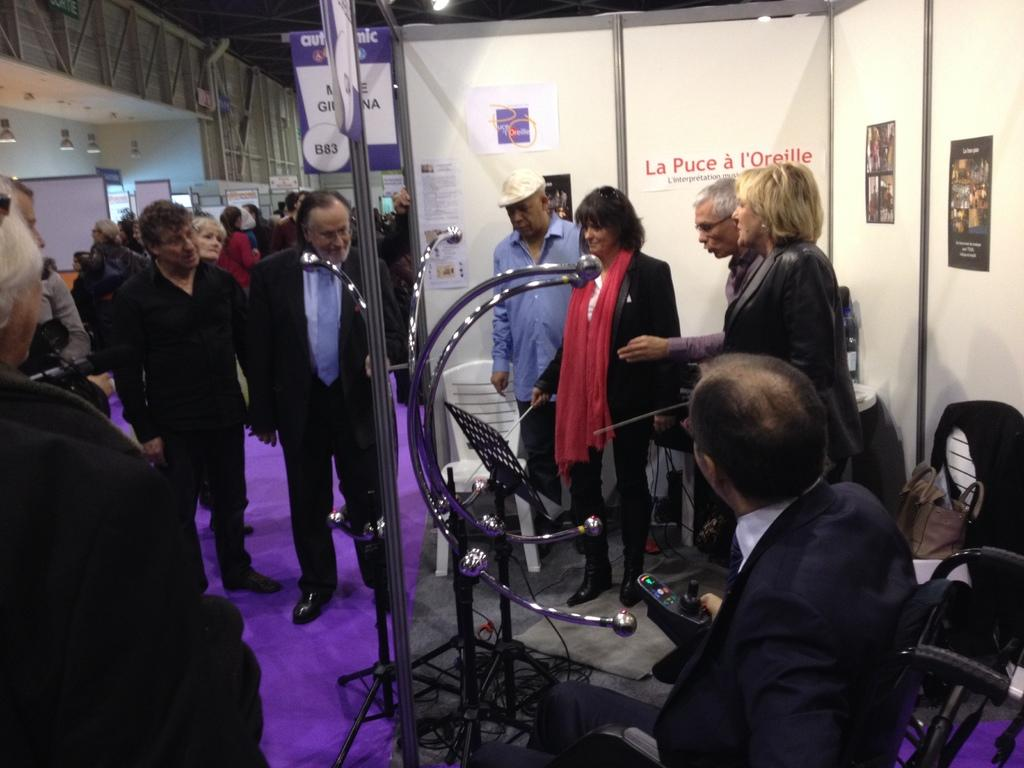What can be seen on the boards in the image? There are boards with text in the image. Who or what is present in the image besides the boards? There are people and chairs in the image. What type of lighting is present in the image? There are lights in the image. What structure can be seen in the image that might be used for displaying or supporting items? There is a stand in the image. Can you tell me how many wheels are on the kitty in the image? There is no kitty present in the image, and therefore no wheels can be observed. 